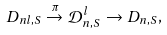Convert formula to latex. <formula><loc_0><loc_0><loc_500><loc_500>D _ { n l , S } \stackrel { \pi } { \rightarrow } \mathcal { D } _ { n , S } ^ { l } \rightarrow D _ { n , S } ,</formula> 